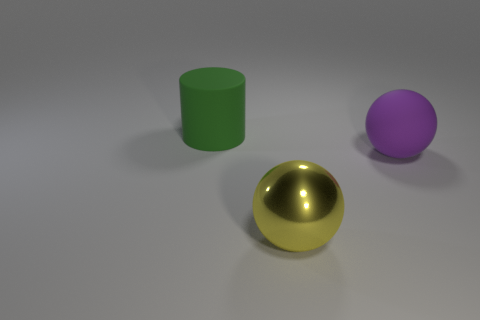What time of day or lighting condition does this scene represent? The scene seems to be artificially lit with a soft, diffused light source, suggesting indoor lighting conditions rather than a specific time of day. 